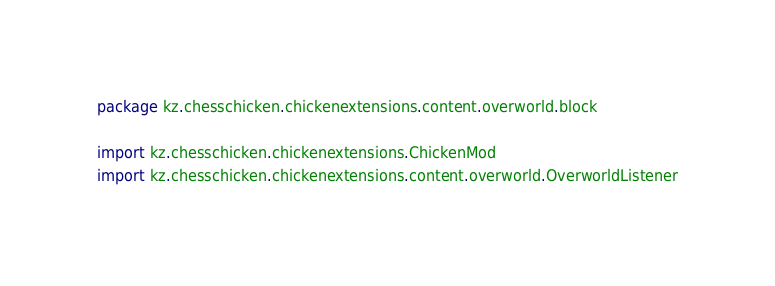Convert code to text. <code><loc_0><loc_0><loc_500><loc_500><_Scala_>package kz.chesschicken.chickenextensions.content.overworld.block

import kz.chesschicken.chickenextensions.ChickenMod
import kz.chesschicken.chickenextensions.content.overworld.OverworldListener</code> 